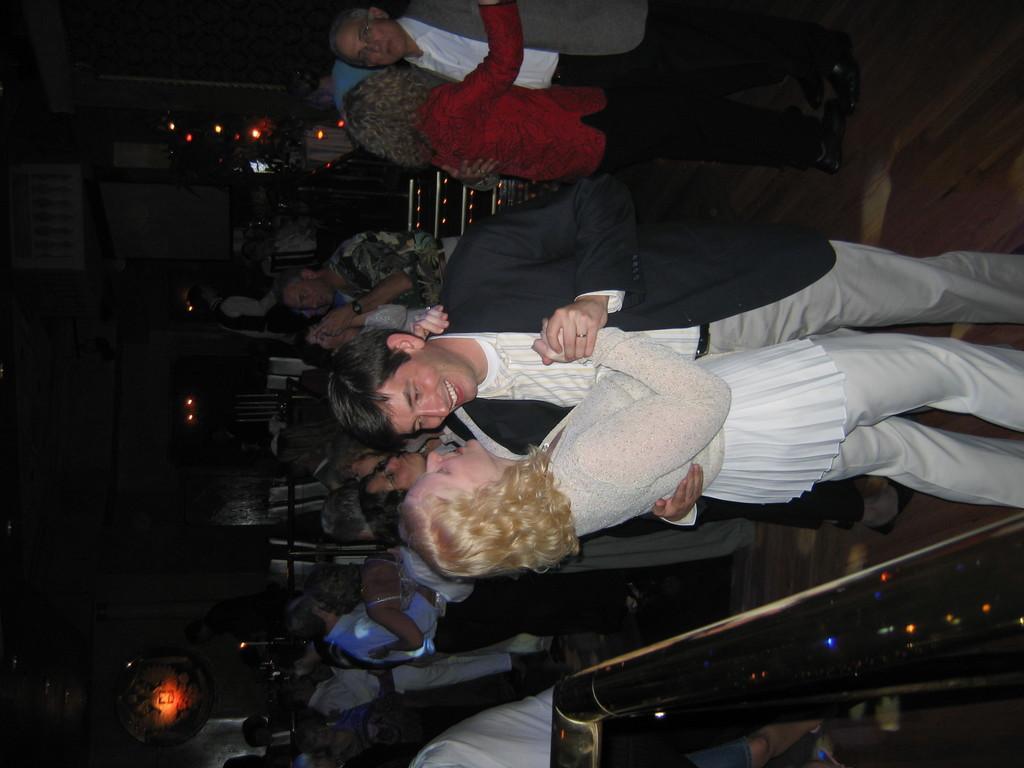How would you summarize this image in a sentence or two? It looks like some club, there are many couples dancing with each other and behind them there are two people and in the background there are few lights. 